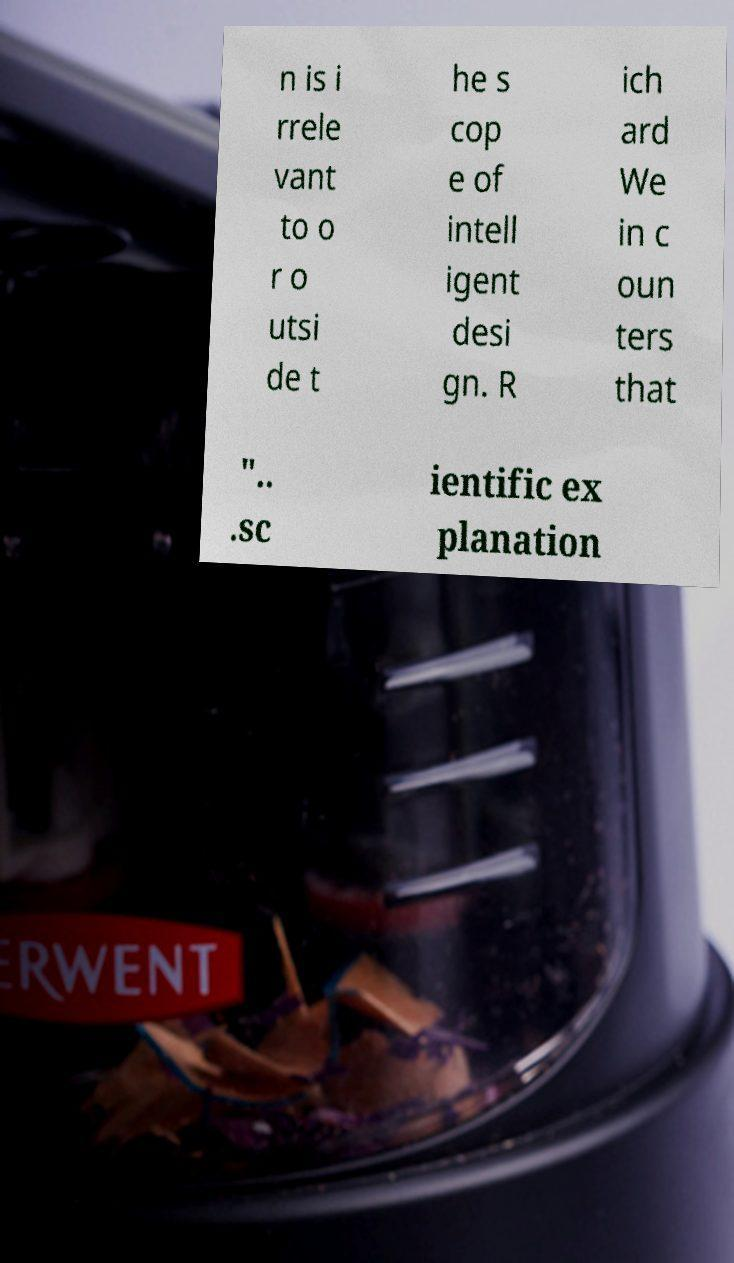Please read and relay the text visible in this image. What does it say? n is i rrele vant to o r o utsi de t he s cop e of intell igent desi gn. R ich ard We in c oun ters that ".. .sc ientific ex planation 